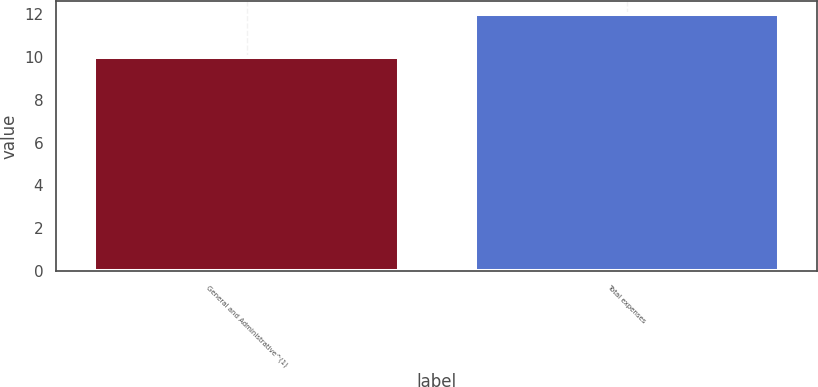<chart> <loc_0><loc_0><loc_500><loc_500><bar_chart><fcel>General and Administrative^(1)<fcel>Total expenses<nl><fcel>10<fcel>12<nl></chart> 